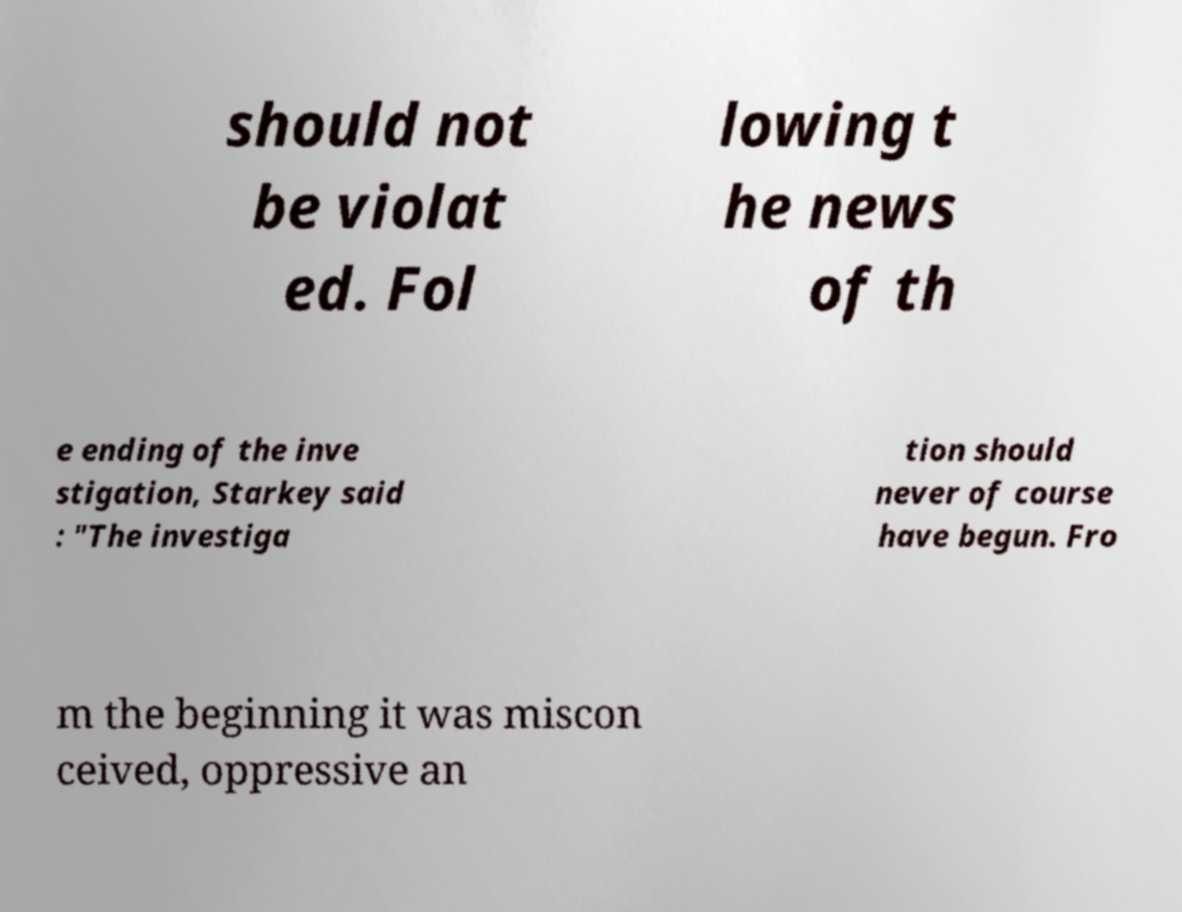Could you extract and type out the text from this image? should not be violat ed. Fol lowing t he news of th e ending of the inve stigation, Starkey said : "The investiga tion should never of course have begun. Fro m the beginning it was miscon ceived, oppressive an 